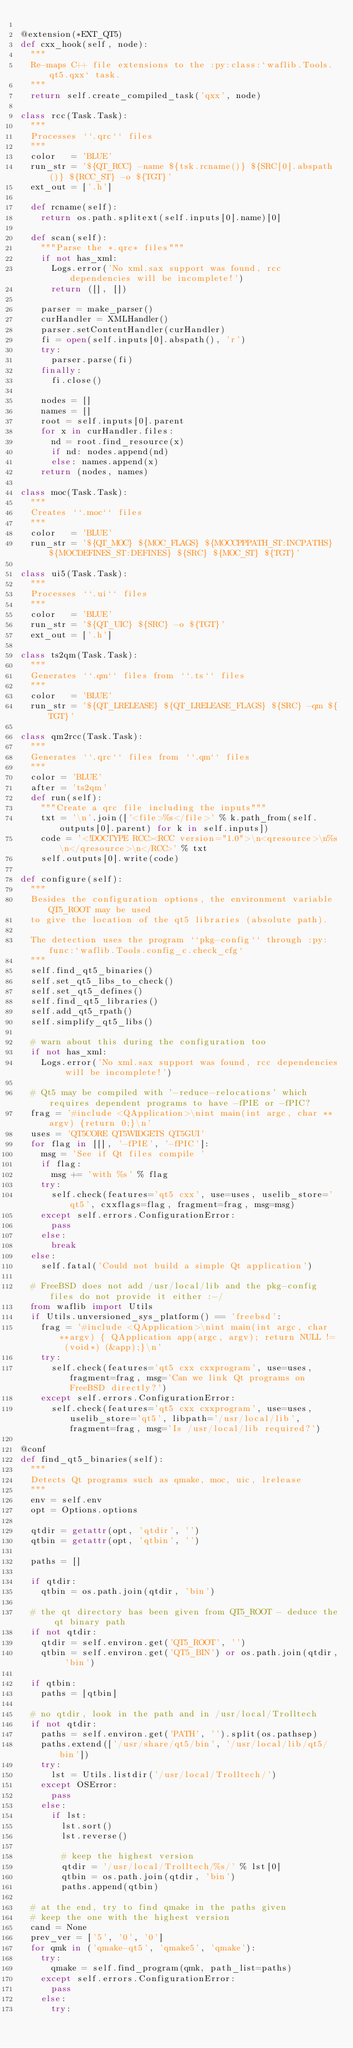<code> <loc_0><loc_0><loc_500><loc_500><_Python_>
@extension(*EXT_QT5)
def cxx_hook(self, node):
	"""
	Re-maps C++ file extensions to the :py:class:`waflib.Tools.qt5.qxx` task.
	"""
	return self.create_compiled_task('qxx', node)

class rcc(Task.Task):
	"""
	Processes ``.qrc`` files
	"""
	color   = 'BLUE'
	run_str = '${QT_RCC} -name ${tsk.rcname()} ${SRC[0].abspath()} ${RCC_ST} -o ${TGT}'
	ext_out = ['.h']

	def rcname(self):
		return os.path.splitext(self.inputs[0].name)[0]

	def scan(self):
		"""Parse the *.qrc* files"""
		if not has_xml:
			Logs.error('No xml.sax support was found, rcc dependencies will be incomplete!')
			return ([], [])

		parser = make_parser()
		curHandler = XMLHandler()
		parser.setContentHandler(curHandler)
		fi = open(self.inputs[0].abspath(), 'r')
		try:
			parser.parse(fi)
		finally:
			fi.close()

		nodes = []
		names = []
		root = self.inputs[0].parent
		for x in curHandler.files:
			nd = root.find_resource(x)
			if nd: nodes.append(nd)
			else: names.append(x)
		return (nodes, names)

class moc(Task.Task):
	"""
	Creates ``.moc`` files
	"""
	color   = 'BLUE'
	run_str = '${QT_MOC} ${MOC_FLAGS} ${MOCCPPPATH_ST:INCPATHS} ${MOCDEFINES_ST:DEFINES} ${SRC} ${MOC_ST} ${TGT}'

class ui5(Task.Task):
	"""
	Processes ``.ui`` files
	"""
	color   = 'BLUE'
	run_str = '${QT_UIC} ${SRC} -o ${TGT}'
	ext_out = ['.h']

class ts2qm(Task.Task):
	"""
	Generates ``.qm`` files from ``.ts`` files
	"""
	color   = 'BLUE'
	run_str = '${QT_LRELEASE} ${QT_LRELEASE_FLAGS} ${SRC} -qm ${TGT}'

class qm2rcc(Task.Task):
	"""
	Generates ``.qrc`` files from ``.qm`` files
	"""
	color = 'BLUE'
	after = 'ts2qm'
	def run(self):
		"""Create a qrc file including the inputs"""
		txt = '\n'.join(['<file>%s</file>' % k.path_from(self.outputs[0].parent) for k in self.inputs])
		code = '<!DOCTYPE RCC><RCC version="1.0">\n<qresource>\n%s\n</qresource>\n</RCC>' % txt
		self.outputs[0].write(code)

def configure(self):
	"""
	Besides the configuration options, the environment variable QT5_ROOT may be used
	to give the location of the qt5 libraries (absolute path).

	The detection uses the program ``pkg-config`` through :py:func:`waflib.Tools.config_c.check_cfg`
	"""
	self.find_qt5_binaries()
	self.set_qt5_libs_to_check()
	self.set_qt5_defines()
	self.find_qt5_libraries()
	self.add_qt5_rpath()
	self.simplify_qt5_libs()

	# warn about this during the configuration too
	if not has_xml:
		Logs.error('No xml.sax support was found, rcc dependencies will be incomplete!')

	# Qt5 may be compiled with '-reduce-relocations' which requires dependent programs to have -fPIE or -fPIC?
	frag = '#include <QApplication>\nint main(int argc, char **argv) {return 0;}\n'
	uses = 'QT5CORE QT5WIDGETS QT5GUI'
	for flag in [[], '-fPIE', '-fPIC']:
		msg = 'See if Qt files compile '
		if flag:
			msg += 'with %s' % flag
		try:
			self.check(features='qt5 cxx', use=uses, uselib_store='qt5', cxxflags=flag, fragment=frag, msg=msg)
		except self.errors.ConfigurationError:
			pass
		else:
			break
	else:
		self.fatal('Could not build a simple Qt application')

	# FreeBSD does not add /usr/local/lib and the pkg-config files do not provide it either :-/
	from waflib import Utils
	if Utils.unversioned_sys_platform() == 'freebsd':
		frag = '#include <QApplication>\nint main(int argc, char **argv) { QApplication app(argc, argv); return NULL != (void*) (&app);}\n'
		try:
			self.check(features='qt5 cxx cxxprogram', use=uses, fragment=frag, msg='Can we link Qt programs on FreeBSD directly?')
		except self.errors.ConfigurationError:
			self.check(features='qt5 cxx cxxprogram', use=uses, uselib_store='qt5', libpath='/usr/local/lib', fragment=frag, msg='Is /usr/local/lib required?')

@conf
def find_qt5_binaries(self):
	"""
	Detects Qt programs such as qmake, moc, uic, lrelease
	"""
	env = self.env
	opt = Options.options

	qtdir = getattr(opt, 'qtdir', '')
	qtbin = getattr(opt, 'qtbin', '')

	paths = []

	if qtdir:
		qtbin = os.path.join(qtdir, 'bin')

	# the qt directory has been given from QT5_ROOT - deduce the qt binary path
	if not qtdir:
		qtdir = self.environ.get('QT5_ROOT', '')
		qtbin = self.environ.get('QT5_BIN') or os.path.join(qtdir, 'bin')

	if qtbin:
		paths = [qtbin]

	# no qtdir, look in the path and in /usr/local/Trolltech
	if not qtdir:
		paths = self.environ.get('PATH', '').split(os.pathsep)
		paths.extend(['/usr/share/qt5/bin', '/usr/local/lib/qt5/bin'])
		try:
			lst = Utils.listdir('/usr/local/Trolltech/')
		except OSError:
			pass
		else:
			if lst:
				lst.sort()
				lst.reverse()

				# keep the highest version
				qtdir = '/usr/local/Trolltech/%s/' % lst[0]
				qtbin = os.path.join(qtdir, 'bin')
				paths.append(qtbin)

	# at the end, try to find qmake in the paths given
	# keep the one with the highest version
	cand = None
	prev_ver = ['5', '0', '0']
	for qmk in ('qmake-qt5', 'qmake5', 'qmake'):
		try:
			qmake = self.find_program(qmk, path_list=paths)
		except self.errors.ConfigurationError:
			pass
		else:
			try:</code> 